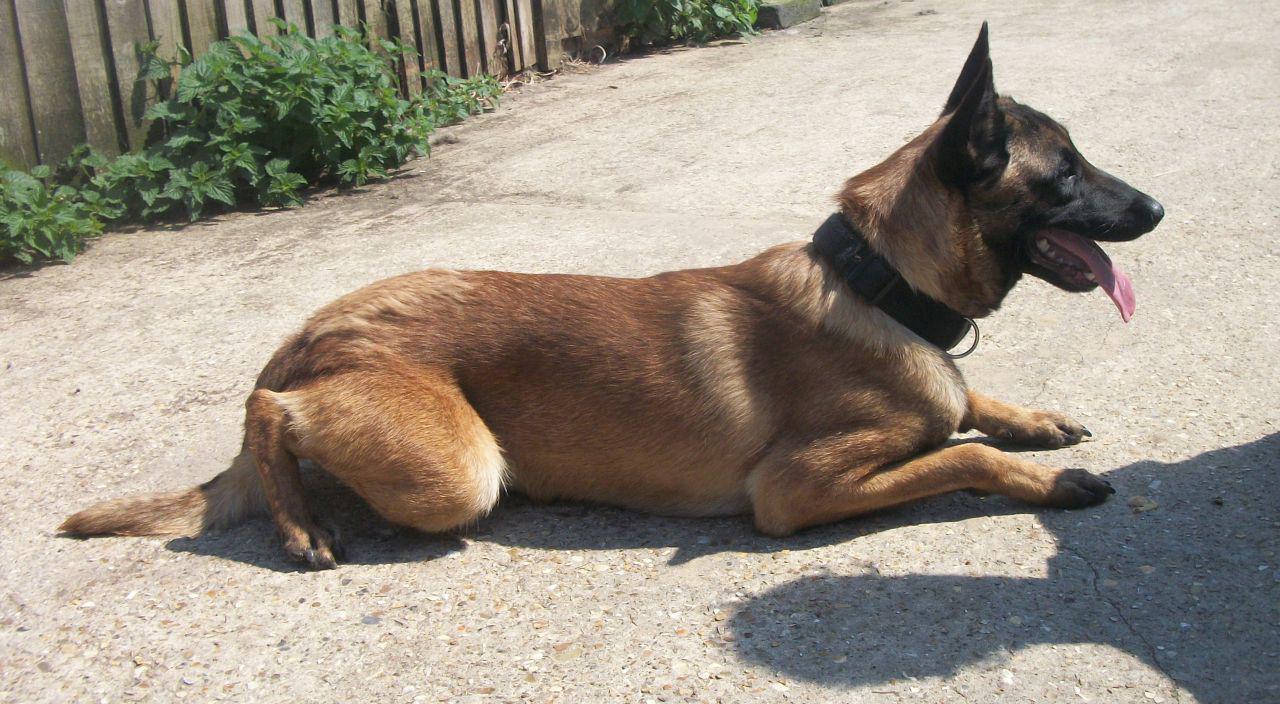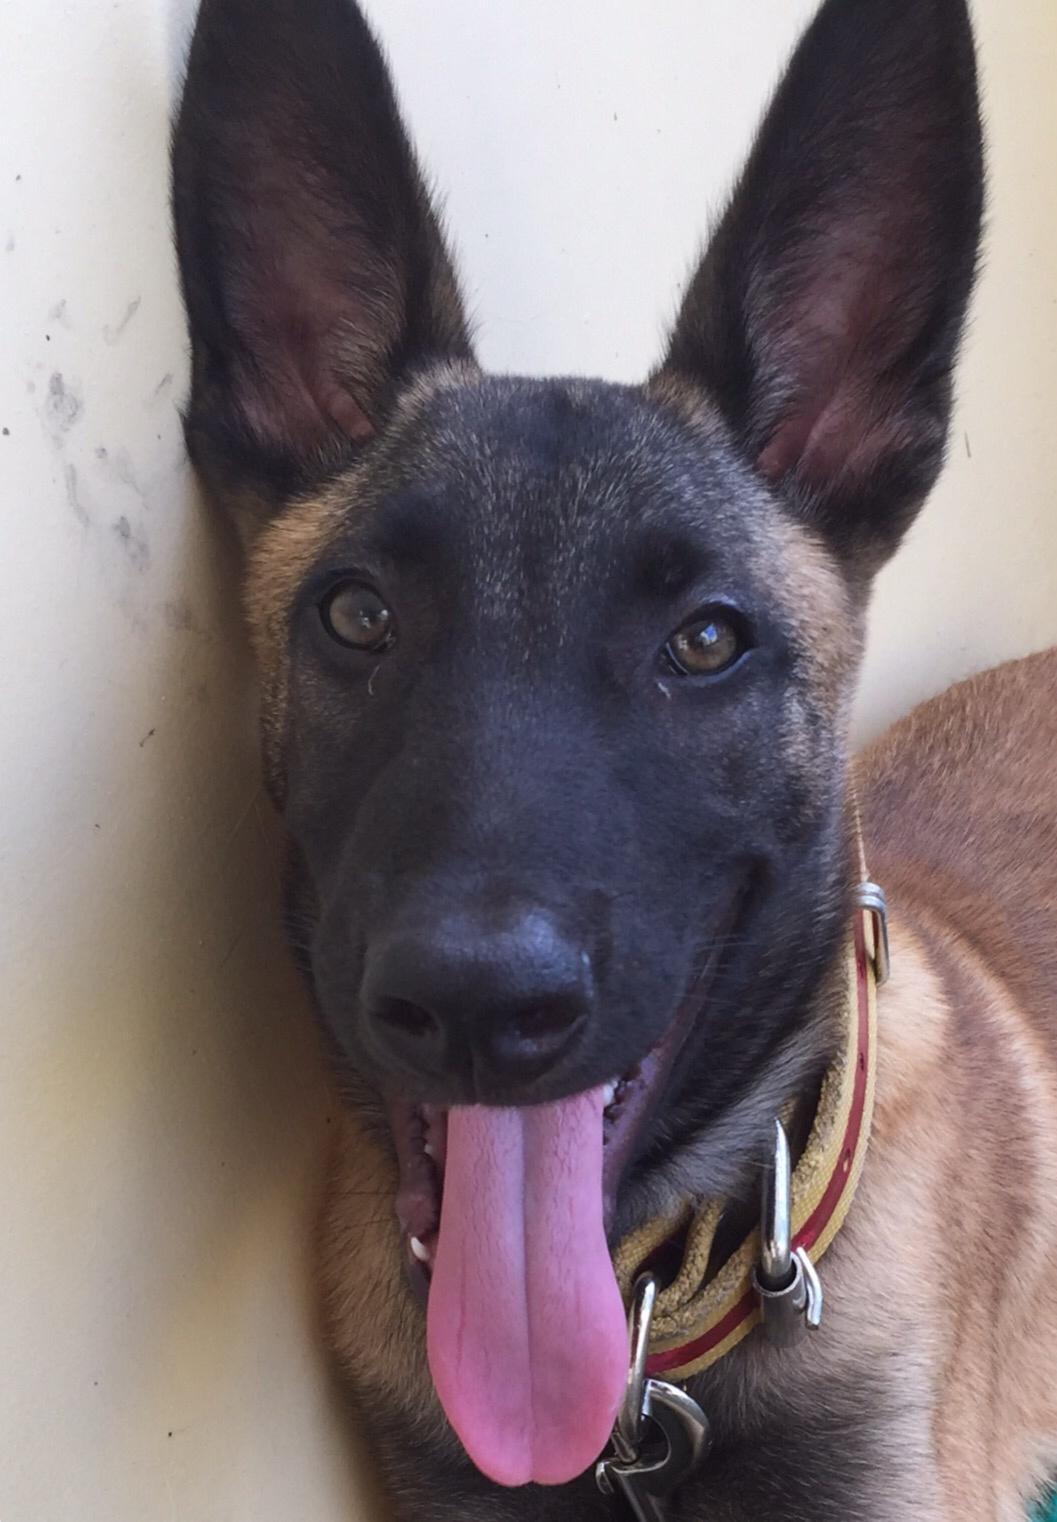The first image is the image on the left, the second image is the image on the right. Considering the images on both sides, is "There is at least one dog sticking its tongue out." valid? Answer yes or no. Yes. The first image is the image on the left, the second image is the image on the right. Assess this claim about the two images: "A large-eared dog's tongue is visible as it faces the camera.". Correct or not? Answer yes or no. Yes. 